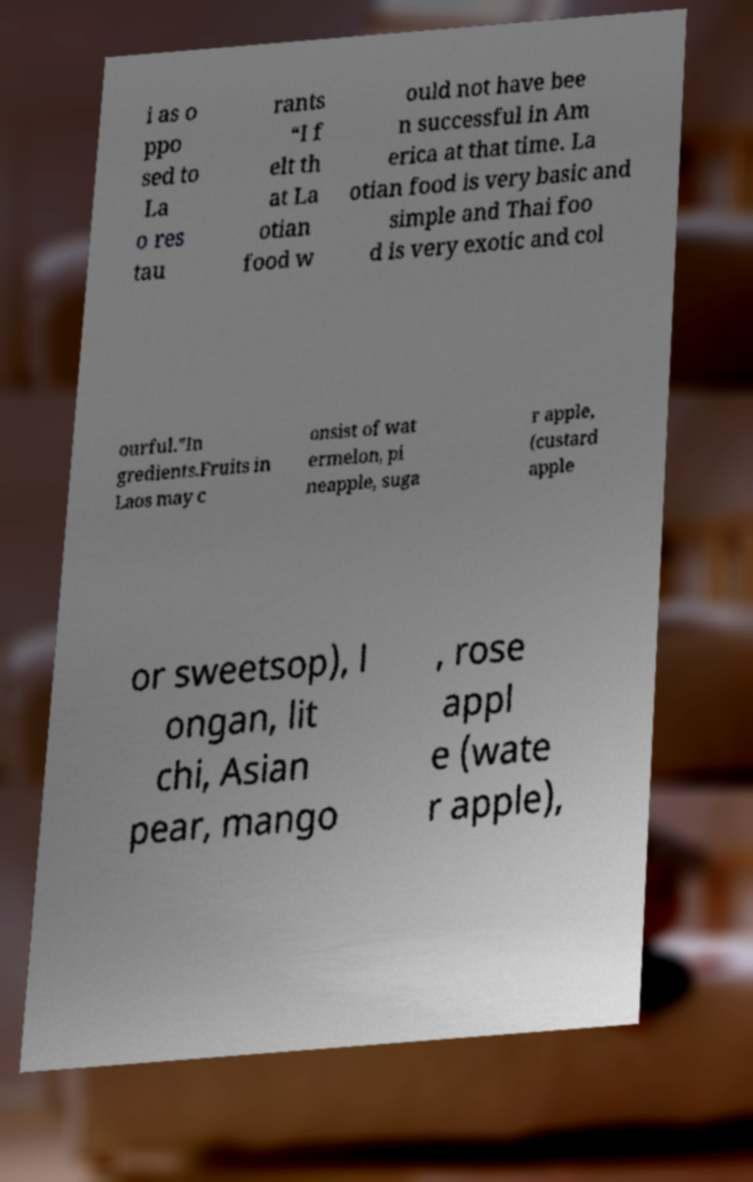There's text embedded in this image that I need extracted. Can you transcribe it verbatim? i as o ppo sed to La o res tau rants “I f elt th at La otian food w ould not have bee n successful in Am erica at that time. La otian food is very basic and simple and Thai foo d is very exotic and col ourful.”In gredients.Fruits in Laos may c onsist of wat ermelon, pi neapple, suga r apple, (custard apple or sweetsop), l ongan, lit chi, Asian pear, mango , rose appl e (wate r apple), 